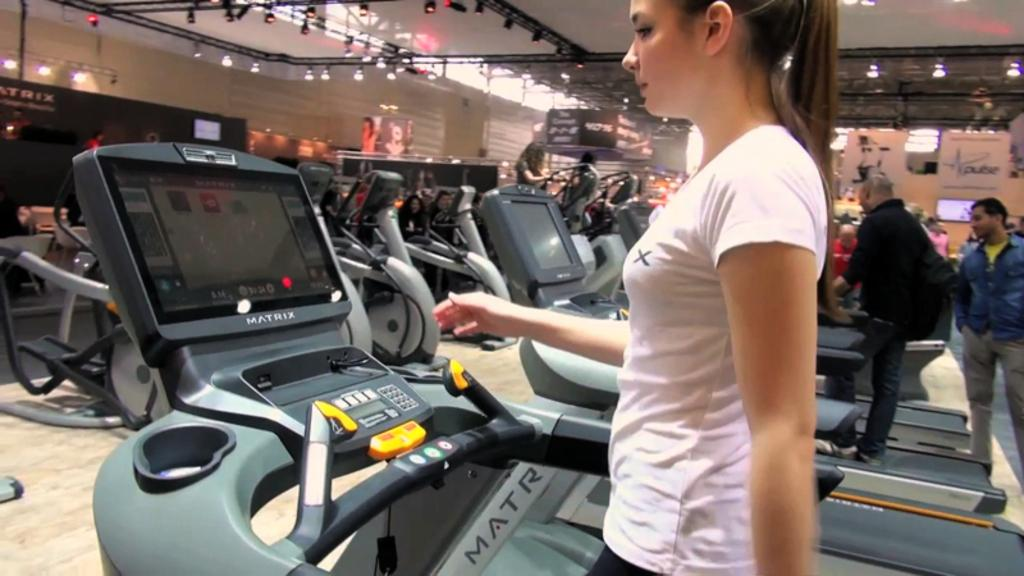What type of equipment can be seen in the image? There is gym equipment in the image. Are there any people present in the image? Yes, there are people in the image. What can be seen on the wall in the image? There is a screen in the image. What type of lighting is present in the image? There are lights in the image. What type of signage is visible in the image? There is a hoarding in the image. What type of flat surface is present in the image? There are boards in the image. What are some people doing with the gym equipment? Some people are standing on the gym equipment. What type of drum can be heard playing in the image? There is no drum present in the image, and therefore no sound can be heard. What time of day is it in the image? The time of day cannot be determined from the image alone. 